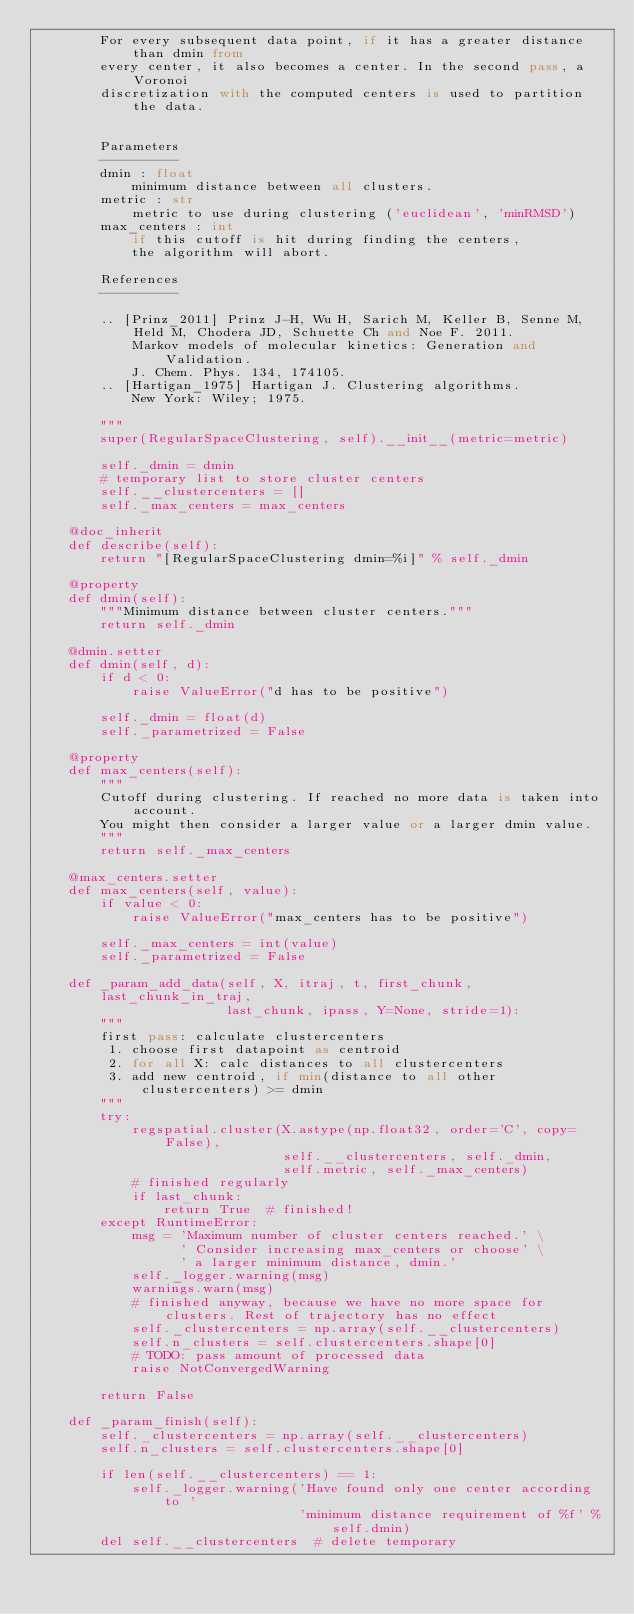<code> <loc_0><loc_0><loc_500><loc_500><_Python_>        For every subsequent data point, if it has a greater distance than dmin from
        every center, it also becomes a center. In the second pass, a Voronoi
        discretization with the computed centers is used to partition the data.


        Parameters
        ----------
        dmin : float
            minimum distance between all clusters.
        metric : str
            metric to use during clustering ('euclidean', 'minRMSD')
        max_centers : int
            if this cutoff is hit during finding the centers,
            the algorithm will abort.

        References
        ----------

        .. [Prinz_2011] Prinz J-H, Wu H, Sarich M, Keller B, Senne M, Held M, Chodera JD, Schuette Ch and Noe F. 2011.
            Markov models of molecular kinetics: Generation and Validation.
            J. Chem. Phys. 134, 174105.
        .. [Hartigan_1975] Hartigan J. Clustering algorithms.
            New York: Wiley; 1975.

        """
        super(RegularSpaceClustering, self).__init__(metric=metric)

        self._dmin = dmin
        # temporary list to store cluster centers
        self.__clustercenters = []
        self._max_centers = max_centers

    @doc_inherit
    def describe(self):
        return "[RegularSpaceClustering dmin=%i]" % self._dmin

    @property
    def dmin(self):
        """Minimum distance between cluster centers."""
        return self._dmin

    @dmin.setter
    def dmin(self, d):
        if d < 0:
            raise ValueError("d has to be positive")

        self._dmin = float(d)
        self._parametrized = False

    @property
    def max_centers(self):
        """
        Cutoff during clustering. If reached no more data is taken into account.
        You might then consider a larger value or a larger dmin value.
        """
        return self._max_centers

    @max_centers.setter
    def max_centers(self, value):
        if value < 0:
            raise ValueError("max_centers has to be positive")

        self._max_centers = int(value)
        self._parametrized = False

    def _param_add_data(self, X, itraj, t, first_chunk, last_chunk_in_traj,
                        last_chunk, ipass, Y=None, stride=1):
        """
        first pass: calculate clustercenters
         1. choose first datapoint as centroid
         2. for all X: calc distances to all clustercenters
         3. add new centroid, if min(distance to all other clustercenters) >= dmin
        """
        try:
            regspatial.cluster(X.astype(np.float32, order='C', copy=False),
                               self.__clustercenters, self._dmin,
                               self.metric, self._max_centers)
            # finished regularly
            if last_chunk:
                return True  # finished!
        except RuntimeError:
            msg = 'Maximum number of cluster centers reached.' \
                  ' Consider increasing max_centers or choose' \
                  ' a larger minimum distance, dmin.'
            self._logger.warning(msg)
            warnings.warn(msg)
            # finished anyway, because we have no more space for clusters. Rest of trajectory has no effect
            self._clustercenters = np.array(self.__clustercenters)
            self.n_clusters = self.clustercenters.shape[0]
            # TODO: pass amount of processed data
            raise NotConvergedWarning

        return False

    def _param_finish(self):
        self._clustercenters = np.array(self.__clustercenters)
        self.n_clusters = self.clustercenters.shape[0]

        if len(self.__clustercenters) == 1:
            self._logger.warning('Have found only one center according to '
                                 'minimum distance requirement of %f' % self.dmin)
        del self.__clustercenters  # delete temporary
</code> 